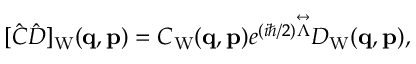<formula> <loc_0><loc_0><loc_500><loc_500>\begin{array} { r } { [ \hat { C } \hat { D } ] _ { W } ( { q } , { p } ) = C _ { W } ( { q } , { p } ) e ^ { ( i \hbar { / } 2 ) \overset { \leftrightarrow } \Lambda } } D _ { W } ( { q } , { p } ) , } \end{array}</formula> 